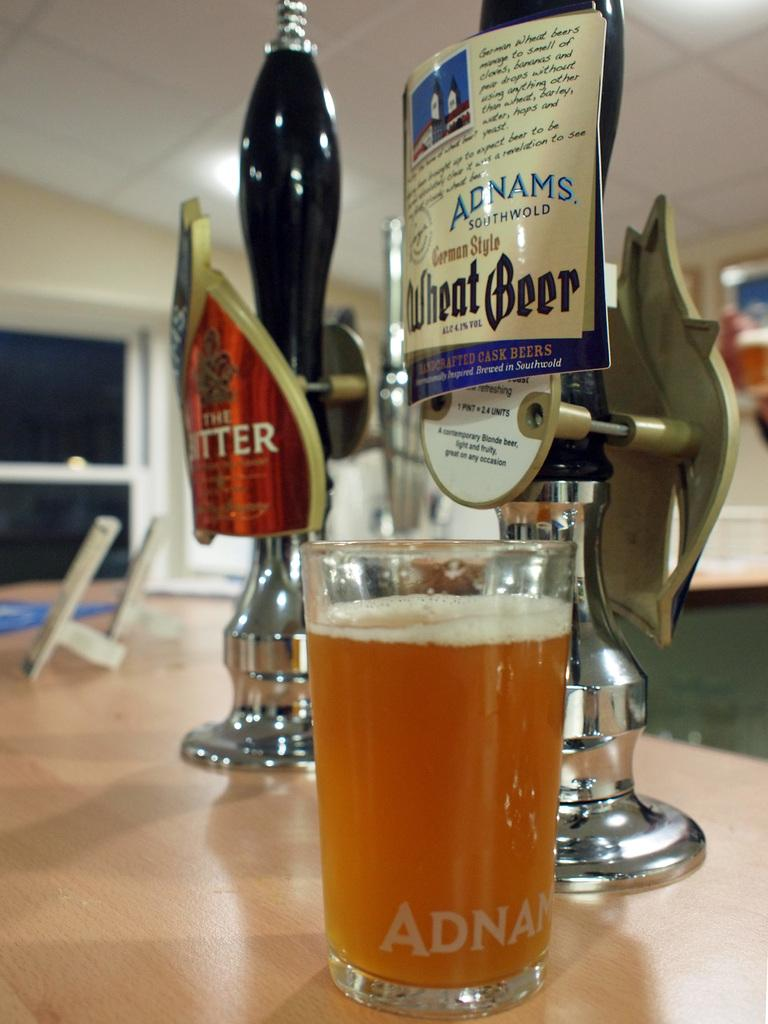<image>
Give a short and clear explanation of the subsequent image. Beer tap which says Wheat beer and has a full cup under it. 